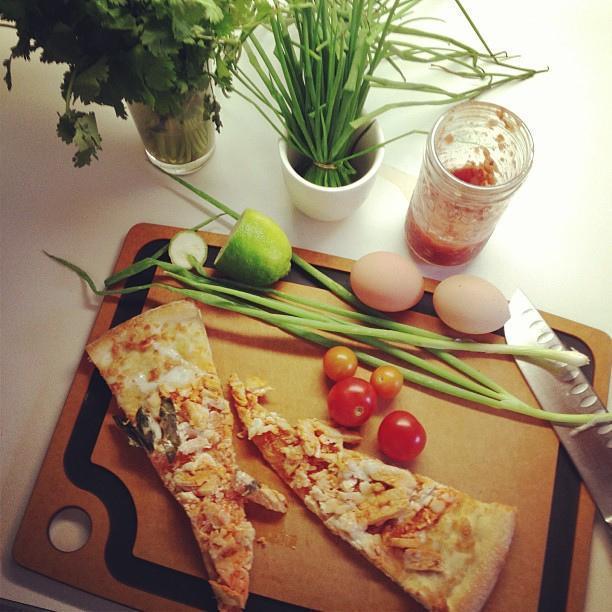How many pieces of pizza are there?
Give a very brief answer. 2. How many pizzas are visible?
Give a very brief answer. 2. How many cups are visible?
Give a very brief answer. 2. 